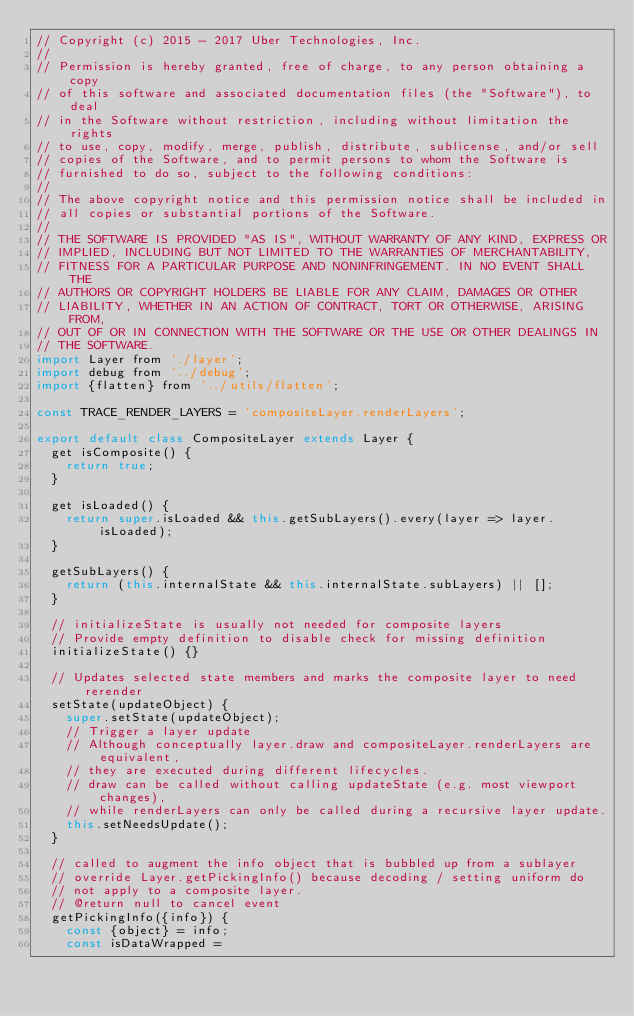Convert code to text. <code><loc_0><loc_0><loc_500><loc_500><_JavaScript_>// Copyright (c) 2015 - 2017 Uber Technologies, Inc.
//
// Permission is hereby granted, free of charge, to any person obtaining a copy
// of this software and associated documentation files (the "Software"), to deal
// in the Software without restriction, including without limitation the rights
// to use, copy, modify, merge, publish, distribute, sublicense, and/or sell
// copies of the Software, and to permit persons to whom the Software is
// furnished to do so, subject to the following conditions:
//
// The above copyright notice and this permission notice shall be included in
// all copies or substantial portions of the Software.
//
// THE SOFTWARE IS PROVIDED "AS IS", WITHOUT WARRANTY OF ANY KIND, EXPRESS OR
// IMPLIED, INCLUDING BUT NOT LIMITED TO THE WARRANTIES OF MERCHANTABILITY,
// FITNESS FOR A PARTICULAR PURPOSE AND NONINFRINGEMENT. IN NO EVENT SHALL THE
// AUTHORS OR COPYRIGHT HOLDERS BE LIABLE FOR ANY CLAIM, DAMAGES OR OTHER
// LIABILITY, WHETHER IN AN ACTION OF CONTRACT, TORT OR OTHERWISE, ARISING FROM,
// OUT OF OR IN CONNECTION WITH THE SOFTWARE OR THE USE OR OTHER DEALINGS IN
// THE SOFTWARE.
import Layer from './layer';
import debug from '../debug';
import {flatten} from '../utils/flatten';

const TRACE_RENDER_LAYERS = 'compositeLayer.renderLayers';

export default class CompositeLayer extends Layer {
  get isComposite() {
    return true;
  }

  get isLoaded() {
    return super.isLoaded && this.getSubLayers().every(layer => layer.isLoaded);
  }

  getSubLayers() {
    return (this.internalState && this.internalState.subLayers) || [];
  }

  // initializeState is usually not needed for composite layers
  // Provide empty definition to disable check for missing definition
  initializeState() {}

  // Updates selected state members and marks the composite layer to need rerender
  setState(updateObject) {
    super.setState(updateObject);
    // Trigger a layer update
    // Although conceptually layer.draw and compositeLayer.renderLayers are equivalent,
    // they are executed during different lifecycles.
    // draw can be called without calling updateState (e.g. most viewport changes),
    // while renderLayers can only be called during a recursive layer update.
    this.setNeedsUpdate();
  }

  // called to augment the info object that is bubbled up from a sublayer
  // override Layer.getPickingInfo() because decoding / setting uniform do
  // not apply to a composite layer.
  // @return null to cancel event
  getPickingInfo({info}) {
    const {object} = info;
    const isDataWrapped =</code> 